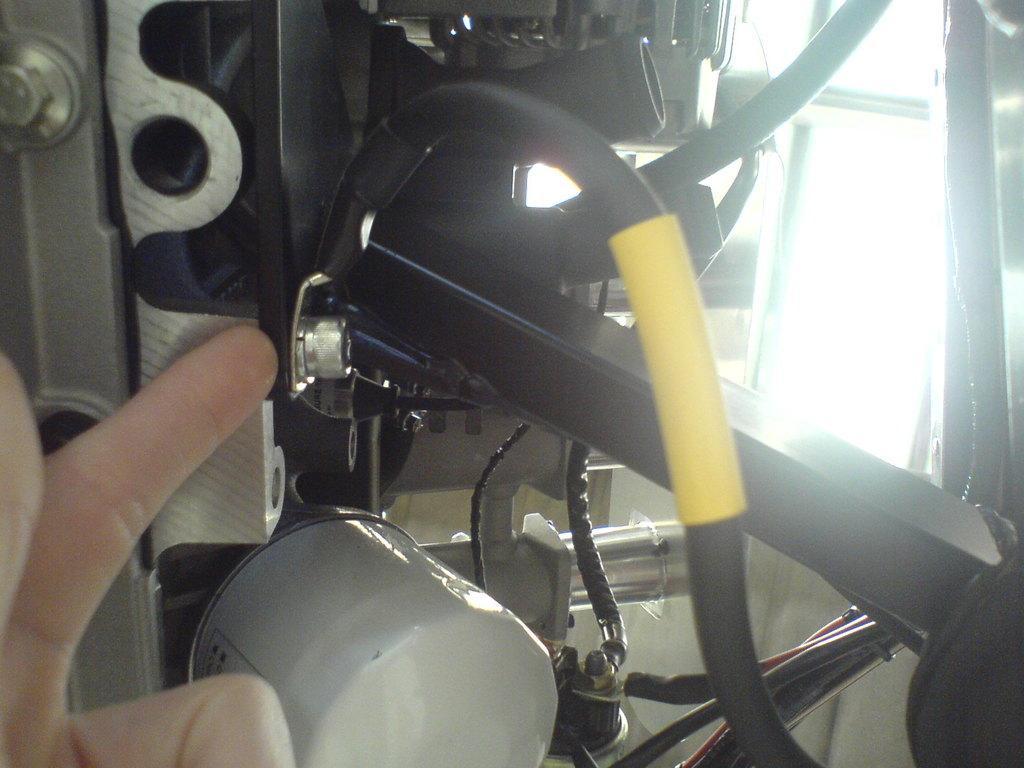In one or two sentences, can you explain what this image depicts? In this picture I can see a machine and a human hand. 